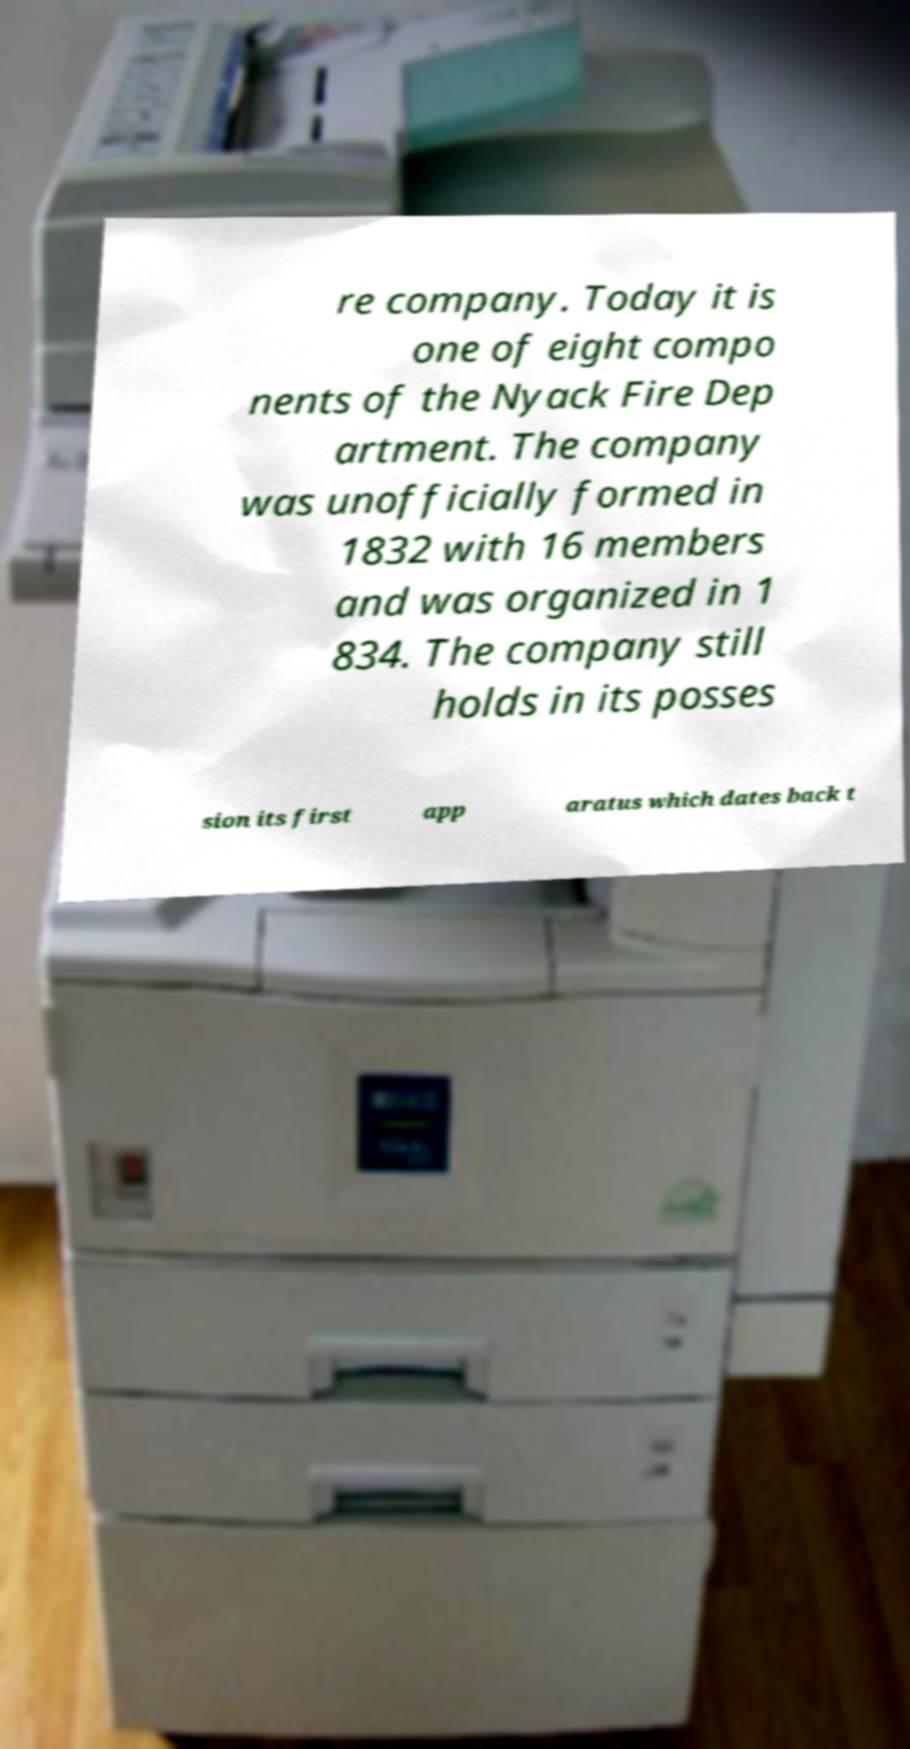I need the written content from this picture converted into text. Can you do that? re company. Today it is one of eight compo nents of the Nyack Fire Dep artment. The company was unofficially formed in 1832 with 16 members and was organized in 1 834. The company still holds in its posses sion its first app aratus which dates back t 